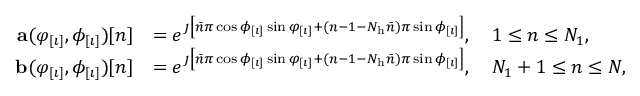<formula> <loc_0><loc_0><loc_500><loc_500>\begin{array} { r l } { a ( \varphi _ { [ \imath ] } , \phi _ { [ \imath ] } ) [ n ] } & { = e ^ { \jmath \left [ \bar { n } \pi \cos \phi _ { [ \imath ] } \sin \varphi _ { [ \imath ] } + ( n - 1 - N _ { h } \bar { n } ) \pi \sin \phi _ { [ \imath ] } \right ] } , \quad 1 \leq n \leq N _ { 1 } , } \\ { b ( \varphi _ { [ \imath ] } , \phi _ { [ \imath ] } ) [ n ] } & { = e ^ { \jmath \left [ \bar { n } \pi \cos \phi _ { [ \imath ] } \sin \varphi _ { [ \imath ] } + ( n - 1 - N _ { h } \bar { n } ) \pi \sin \phi _ { [ \imath ] } \right ] } , \quad N _ { 1 } + 1 \leq n \leq N , } \end{array}</formula> 